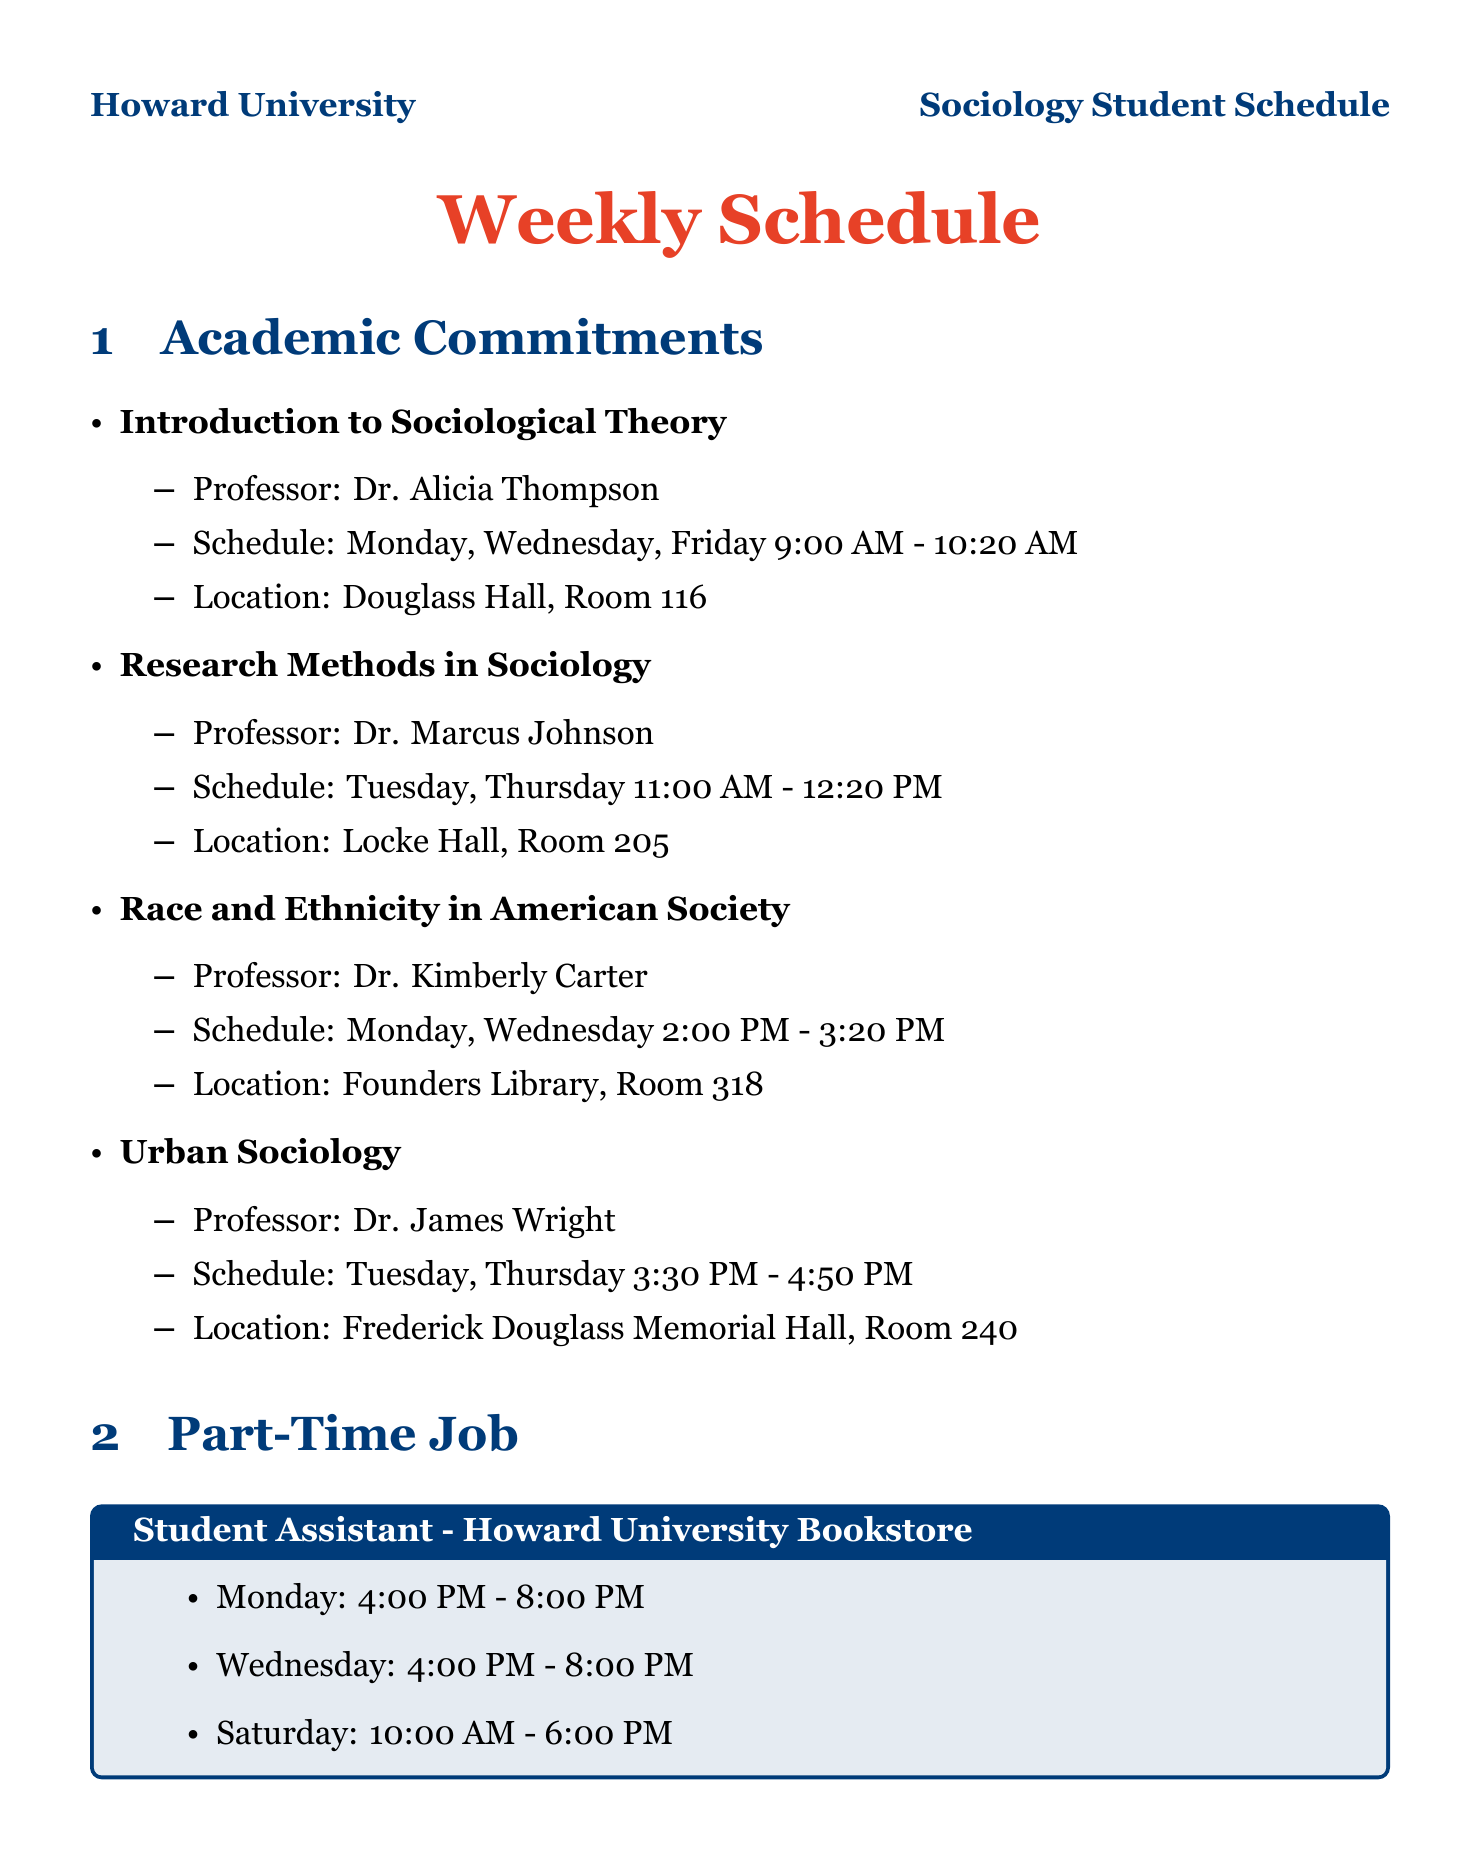what is the name of the professor for Introduction to Sociological Theory? The professor for Introduction to Sociological Theory is mentioned in the document.
Answer: Dr. Alicia Thompson how many courses are scheduled on Tuesday? The document lists academic commitments and their schedules. Only Research Methods in Sociology and Urban Sociology are scheduled on Tuesday.
Answer: 2 when does the Sociology Club meet? The meeting schedule for the Sociology Club is clearly outlined in the document.
Answer: Every other Tuesday, 5:30 PM - 7:00 PM what is the primary location for study sessions on Monday? The document specifies the location for study during various days, and Monday's study location is indicated.
Answer: Founders Library, 2nd Floor how many hours are allocated for personal time daily? The document details the personal time slots included, which add up to multiple hours throughout the week.
Answer: 1 hour which day has a longer shift for the part-time job? By comparing the shifts provided in the part-time job section of the document, the longest shift can be identified.
Answer: Saturday what activity takes place every Thursday evening? A specific extracurricular activity is noted for Thursday evening in the document.
Answer: Black Student Union how many hours are designated for exercise each week? The document indicates exercise times for specific days, allowing for a calculation of total weekly hours.
Answer: 7.5 hours 